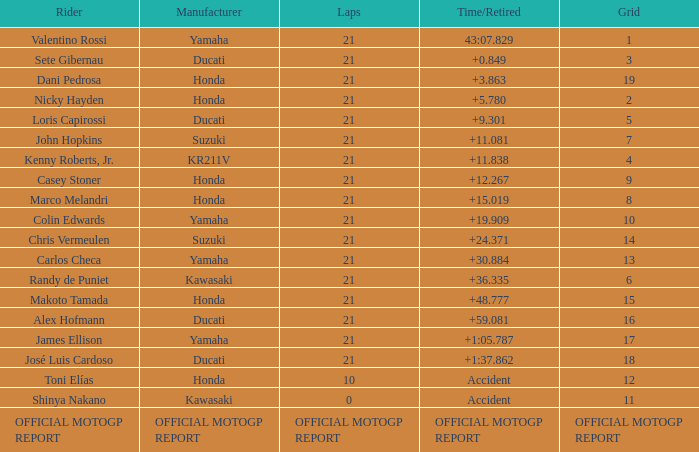How many laps did Valentino rossi have when riding a vehicle manufactured by yamaha? 21.0. 